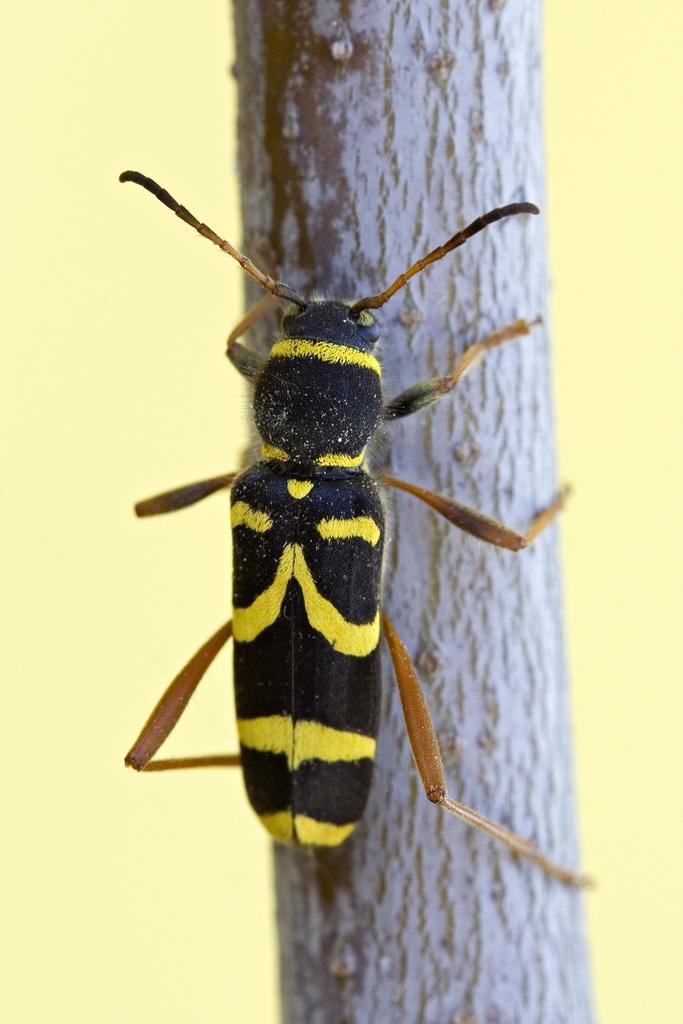In one or two sentences, can you explain what this image depicts? In this image we can see an insect on the wall. In the background we can see the plain wall. 